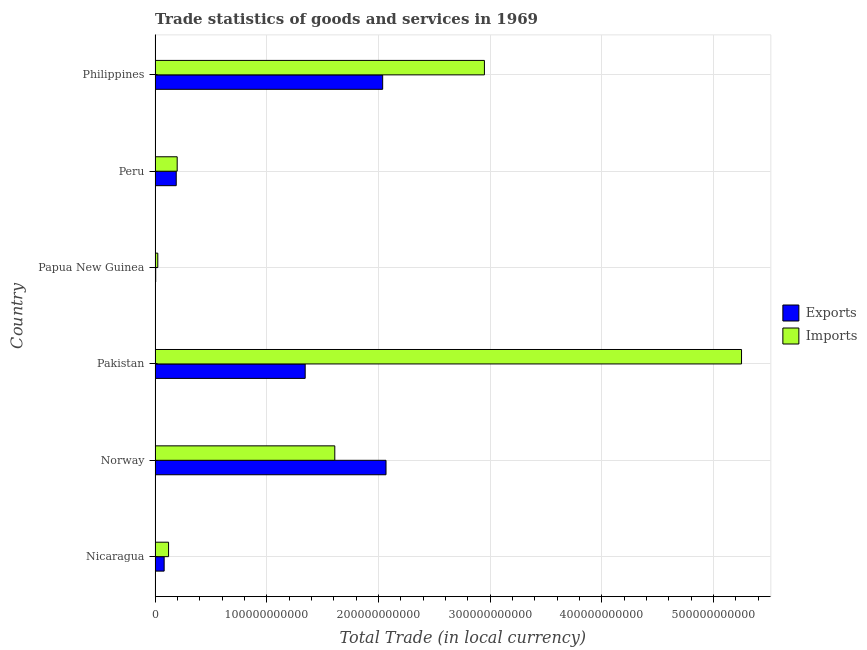How many different coloured bars are there?
Your answer should be compact. 2. How many groups of bars are there?
Offer a terse response. 6. Are the number of bars per tick equal to the number of legend labels?
Your answer should be very brief. Yes. Are the number of bars on each tick of the Y-axis equal?
Ensure brevity in your answer.  Yes. How many bars are there on the 5th tick from the top?
Your answer should be very brief. 2. What is the label of the 1st group of bars from the top?
Offer a terse response. Philippines. In how many cases, is the number of bars for a given country not equal to the number of legend labels?
Your answer should be compact. 0. What is the export of goods and services in Papua New Guinea?
Give a very brief answer. 5.80e+08. Across all countries, what is the maximum imports of goods and services?
Make the answer very short. 5.25e+11. Across all countries, what is the minimum imports of goods and services?
Provide a succinct answer. 2.45e+09. In which country was the imports of goods and services maximum?
Provide a succinct answer. Pakistan. In which country was the export of goods and services minimum?
Provide a succinct answer. Papua New Guinea. What is the total imports of goods and services in the graph?
Give a very brief answer. 1.02e+12. What is the difference between the export of goods and services in Pakistan and that in Peru?
Your answer should be compact. 1.15e+11. What is the difference between the export of goods and services in Peru and the imports of goods and services in Nicaragua?
Your answer should be very brief. 6.88e+09. What is the average export of goods and services per country?
Offer a very short reply. 9.55e+1. What is the difference between the imports of goods and services and export of goods and services in Norway?
Provide a short and direct response. -4.59e+1. What is the ratio of the imports of goods and services in Nicaragua to that in Papua New Guinea?
Offer a very short reply. 4.94. Is the difference between the export of goods and services in Nicaragua and Peru greater than the difference between the imports of goods and services in Nicaragua and Peru?
Give a very brief answer. No. What is the difference between the highest and the second highest export of goods and services?
Ensure brevity in your answer.  2.99e+09. What is the difference between the highest and the lowest imports of goods and services?
Provide a succinct answer. 5.23e+11. Is the sum of the export of goods and services in Papua New Guinea and Philippines greater than the maximum imports of goods and services across all countries?
Provide a succinct answer. No. What does the 1st bar from the top in Papua New Guinea represents?
Offer a terse response. Imports. What does the 2nd bar from the bottom in Norway represents?
Ensure brevity in your answer.  Imports. Are all the bars in the graph horizontal?
Your answer should be compact. Yes. What is the difference between two consecutive major ticks on the X-axis?
Make the answer very short. 1.00e+11. How many legend labels are there?
Your answer should be very brief. 2. How are the legend labels stacked?
Keep it short and to the point. Vertical. What is the title of the graph?
Make the answer very short. Trade statistics of goods and services in 1969. Does "Not attending school" appear as one of the legend labels in the graph?
Your answer should be compact. No. What is the label or title of the X-axis?
Offer a terse response. Total Trade (in local currency). What is the label or title of the Y-axis?
Offer a terse response. Country. What is the Total Trade (in local currency) in Exports in Nicaragua?
Offer a very short reply. 8.14e+09. What is the Total Trade (in local currency) of Imports in Nicaragua?
Provide a succinct answer. 1.21e+1. What is the Total Trade (in local currency) of Exports in Norway?
Your response must be concise. 2.07e+11. What is the Total Trade (in local currency) in Imports in Norway?
Provide a succinct answer. 1.61e+11. What is the Total Trade (in local currency) in Exports in Pakistan?
Ensure brevity in your answer.  1.34e+11. What is the Total Trade (in local currency) in Imports in Pakistan?
Provide a short and direct response. 5.25e+11. What is the Total Trade (in local currency) in Exports in Papua New Guinea?
Ensure brevity in your answer.  5.80e+08. What is the Total Trade (in local currency) of Imports in Papua New Guinea?
Your response must be concise. 2.45e+09. What is the Total Trade (in local currency) of Exports in Peru?
Your answer should be very brief. 1.90e+1. What is the Total Trade (in local currency) in Imports in Peru?
Offer a terse response. 1.98e+1. What is the Total Trade (in local currency) in Exports in Philippines?
Offer a terse response. 2.04e+11. What is the Total Trade (in local currency) in Imports in Philippines?
Your answer should be very brief. 2.95e+11. Across all countries, what is the maximum Total Trade (in local currency) in Exports?
Provide a short and direct response. 2.07e+11. Across all countries, what is the maximum Total Trade (in local currency) of Imports?
Make the answer very short. 5.25e+11. Across all countries, what is the minimum Total Trade (in local currency) of Exports?
Offer a very short reply. 5.80e+08. Across all countries, what is the minimum Total Trade (in local currency) in Imports?
Provide a short and direct response. 2.45e+09. What is the total Total Trade (in local currency) of Exports in the graph?
Keep it short and to the point. 5.73e+11. What is the total Total Trade (in local currency) in Imports in the graph?
Keep it short and to the point. 1.02e+12. What is the difference between the Total Trade (in local currency) of Exports in Nicaragua and that in Norway?
Provide a succinct answer. -1.99e+11. What is the difference between the Total Trade (in local currency) in Imports in Nicaragua and that in Norway?
Offer a very short reply. -1.49e+11. What is the difference between the Total Trade (in local currency) of Exports in Nicaragua and that in Pakistan?
Offer a very short reply. -1.26e+11. What is the difference between the Total Trade (in local currency) in Imports in Nicaragua and that in Pakistan?
Your response must be concise. -5.13e+11. What is the difference between the Total Trade (in local currency) of Exports in Nicaragua and that in Papua New Guinea?
Your answer should be compact. 7.56e+09. What is the difference between the Total Trade (in local currency) in Imports in Nicaragua and that in Papua New Guinea?
Offer a very short reply. 9.64e+09. What is the difference between the Total Trade (in local currency) of Exports in Nicaragua and that in Peru?
Your response must be concise. -1.08e+1. What is the difference between the Total Trade (in local currency) of Imports in Nicaragua and that in Peru?
Your answer should be compact. -7.73e+09. What is the difference between the Total Trade (in local currency) in Exports in Nicaragua and that in Philippines?
Your response must be concise. -1.96e+11. What is the difference between the Total Trade (in local currency) in Imports in Nicaragua and that in Philippines?
Make the answer very short. -2.83e+11. What is the difference between the Total Trade (in local currency) of Exports in Norway and that in Pakistan?
Keep it short and to the point. 7.24e+1. What is the difference between the Total Trade (in local currency) of Imports in Norway and that in Pakistan?
Give a very brief answer. -3.64e+11. What is the difference between the Total Trade (in local currency) of Exports in Norway and that in Papua New Guinea?
Offer a terse response. 2.06e+11. What is the difference between the Total Trade (in local currency) of Imports in Norway and that in Papua New Guinea?
Make the answer very short. 1.58e+11. What is the difference between the Total Trade (in local currency) in Exports in Norway and that in Peru?
Your answer should be very brief. 1.88e+11. What is the difference between the Total Trade (in local currency) in Imports in Norway and that in Peru?
Your response must be concise. 1.41e+11. What is the difference between the Total Trade (in local currency) of Exports in Norway and that in Philippines?
Offer a very short reply. 2.99e+09. What is the difference between the Total Trade (in local currency) of Imports in Norway and that in Philippines?
Give a very brief answer. -1.34e+11. What is the difference between the Total Trade (in local currency) in Exports in Pakistan and that in Papua New Guinea?
Ensure brevity in your answer.  1.34e+11. What is the difference between the Total Trade (in local currency) in Imports in Pakistan and that in Papua New Guinea?
Your answer should be very brief. 5.23e+11. What is the difference between the Total Trade (in local currency) in Exports in Pakistan and that in Peru?
Your answer should be very brief. 1.15e+11. What is the difference between the Total Trade (in local currency) in Imports in Pakistan and that in Peru?
Keep it short and to the point. 5.05e+11. What is the difference between the Total Trade (in local currency) in Exports in Pakistan and that in Philippines?
Provide a succinct answer. -6.94e+1. What is the difference between the Total Trade (in local currency) in Imports in Pakistan and that in Philippines?
Offer a terse response. 2.30e+11. What is the difference between the Total Trade (in local currency) in Exports in Papua New Guinea and that in Peru?
Ensure brevity in your answer.  -1.84e+1. What is the difference between the Total Trade (in local currency) in Imports in Papua New Guinea and that in Peru?
Give a very brief answer. -1.74e+1. What is the difference between the Total Trade (in local currency) of Exports in Papua New Guinea and that in Philippines?
Ensure brevity in your answer.  -2.03e+11. What is the difference between the Total Trade (in local currency) of Imports in Papua New Guinea and that in Philippines?
Ensure brevity in your answer.  -2.92e+11. What is the difference between the Total Trade (in local currency) in Exports in Peru and that in Philippines?
Provide a short and direct response. -1.85e+11. What is the difference between the Total Trade (in local currency) in Imports in Peru and that in Philippines?
Ensure brevity in your answer.  -2.75e+11. What is the difference between the Total Trade (in local currency) of Exports in Nicaragua and the Total Trade (in local currency) of Imports in Norway?
Give a very brief answer. -1.53e+11. What is the difference between the Total Trade (in local currency) in Exports in Nicaragua and the Total Trade (in local currency) in Imports in Pakistan?
Your response must be concise. -5.17e+11. What is the difference between the Total Trade (in local currency) of Exports in Nicaragua and the Total Trade (in local currency) of Imports in Papua New Guinea?
Give a very brief answer. 5.69e+09. What is the difference between the Total Trade (in local currency) in Exports in Nicaragua and the Total Trade (in local currency) in Imports in Peru?
Offer a very short reply. -1.17e+1. What is the difference between the Total Trade (in local currency) in Exports in Nicaragua and the Total Trade (in local currency) in Imports in Philippines?
Offer a very short reply. -2.87e+11. What is the difference between the Total Trade (in local currency) in Exports in Norway and the Total Trade (in local currency) in Imports in Pakistan?
Ensure brevity in your answer.  -3.18e+11. What is the difference between the Total Trade (in local currency) in Exports in Norway and the Total Trade (in local currency) in Imports in Papua New Guinea?
Your answer should be compact. 2.04e+11. What is the difference between the Total Trade (in local currency) of Exports in Norway and the Total Trade (in local currency) of Imports in Peru?
Your answer should be compact. 1.87e+11. What is the difference between the Total Trade (in local currency) of Exports in Norway and the Total Trade (in local currency) of Imports in Philippines?
Provide a succinct answer. -8.81e+1. What is the difference between the Total Trade (in local currency) of Exports in Pakistan and the Total Trade (in local currency) of Imports in Papua New Guinea?
Give a very brief answer. 1.32e+11. What is the difference between the Total Trade (in local currency) of Exports in Pakistan and the Total Trade (in local currency) of Imports in Peru?
Make the answer very short. 1.15e+11. What is the difference between the Total Trade (in local currency) in Exports in Pakistan and the Total Trade (in local currency) in Imports in Philippines?
Keep it short and to the point. -1.60e+11. What is the difference between the Total Trade (in local currency) in Exports in Papua New Guinea and the Total Trade (in local currency) in Imports in Peru?
Provide a succinct answer. -1.92e+1. What is the difference between the Total Trade (in local currency) of Exports in Papua New Guinea and the Total Trade (in local currency) of Imports in Philippines?
Your response must be concise. -2.94e+11. What is the difference between the Total Trade (in local currency) in Exports in Peru and the Total Trade (in local currency) in Imports in Philippines?
Offer a very short reply. -2.76e+11. What is the average Total Trade (in local currency) of Exports per country?
Keep it short and to the point. 9.55e+1. What is the average Total Trade (in local currency) of Imports per country?
Offer a very short reply. 1.69e+11. What is the difference between the Total Trade (in local currency) in Exports and Total Trade (in local currency) in Imports in Nicaragua?
Offer a very short reply. -3.94e+09. What is the difference between the Total Trade (in local currency) in Exports and Total Trade (in local currency) in Imports in Norway?
Offer a very short reply. 4.59e+1. What is the difference between the Total Trade (in local currency) in Exports and Total Trade (in local currency) in Imports in Pakistan?
Make the answer very short. -3.91e+11. What is the difference between the Total Trade (in local currency) in Exports and Total Trade (in local currency) in Imports in Papua New Guinea?
Provide a succinct answer. -1.87e+09. What is the difference between the Total Trade (in local currency) in Exports and Total Trade (in local currency) in Imports in Peru?
Your answer should be very brief. -8.51e+08. What is the difference between the Total Trade (in local currency) in Exports and Total Trade (in local currency) in Imports in Philippines?
Offer a very short reply. -9.11e+1. What is the ratio of the Total Trade (in local currency) of Exports in Nicaragua to that in Norway?
Ensure brevity in your answer.  0.04. What is the ratio of the Total Trade (in local currency) in Imports in Nicaragua to that in Norway?
Give a very brief answer. 0.08. What is the ratio of the Total Trade (in local currency) of Exports in Nicaragua to that in Pakistan?
Provide a succinct answer. 0.06. What is the ratio of the Total Trade (in local currency) in Imports in Nicaragua to that in Pakistan?
Make the answer very short. 0.02. What is the ratio of the Total Trade (in local currency) in Exports in Nicaragua to that in Papua New Guinea?
Make the answer very short. 14.03. What is the ratio of the Total Trade (in local currency) in Imports in Nicaragua to that in Papua New Guinea?
Ensure brevity in your answer.  4.94. What is the ratio of the Total Trade (in local currency) of Exports in Nicaragua to that in Peru?
Offer a very short reply. 0.43. What is the ratio of the Total Trade (in local currency) of Imports in Nicaragua to that in Peru?
Your response must be concise. 0.61. What is the ratio of the Total Trade (in local currency) of Exports in Nicaragua to that in Philippines?
Make the answer very short. 0.04. What is the ratio of the Total Trade (in local currency) of Imports in Nicaragua to that in Philippines?
Your response must be concise. 0.04. What is the ratio of the Total Trade (in local currency) in Exports in Norway to that in Pakistan?
Make the answer very short. 1.54. What is the ratio of the Total Trade (in local currency) in Imports in Norway to that in Pakistan?
Keep it short and to the point. 0.31. What is the ratio of the Total Trade (in local currency) in Exports in Norway to that in Papua New Guinea?
Ensure brevity in your answer.  356.27. What is the ratio of the Total Trade (in local currency) of Imports in Norway to that in Papua New Guinea?
Offer a terse response. 65.74. What is the ratio of the Total Trade (in local currency) of Exports in Norway to that in Peru?
Your response must be concise. 10.91. What is the ratio of the Total Trade (in local currency) of Imports in Norway to that in Peru?
Your answer should be very brief. 8.12. What is the ratio of the Total Trade (in local currency) in Exports in Norway to that in Philippines?
Make the answer very short. 1.01. What is the ratio of the Total Trade (in local currency) in Imports in Norway to that in Philippines?
Provide a short and direct response. 0.55. What is the ratio of the Total Trade (in local currency) of Exports in Pakistan to that in Papua New Guinea?
Provide a short and direct response. 231.58. What is the ratio of the Total Trade (in local currency) of Imports in Pakistan to that in Papua New Guinea?
Provide a short and direct response. 214.52. What is the ratio of the Total Trade (in local currency) in Exports in Pakistan to that in Peru?
Your answer should be very brief. 7.09. What is the ratio of the Total Trade (in local currency) of Imports in Pakistan to that in Peru?
Give a very brief answer. 26.51. What is the ratio of the Total Trade (in local currency) of Exports in Pakistan to that in Philippines?
Your answer should be compact. 0.66. What is the ratio of the Total Trade (in local currency) of Imports in Pakistan to that in Philippines?
Your answer should be very brief. 1.78. What is the ratio of the Total Trade (in local currency) of Exports in Papua New Guinea to that in Peru?
Your answer should be very brief. 0.03. What is the ratio of the Total Trade (in local currency) of Imports in Papua New Guinea to that in Peru?
Provide a succinct answer. 0.12. What is the ratio of the Total Trade (in local currency) of Exports in Papua New Guinea to that in Philippines?
Your answer should be very brief. 0. What is the ratio of the Total Trade (in local currency) of Imports in Papua New Guinea to that in Philippines?
Your answer should be very brief. 0.01. What is the ratio of the Total Trade (in local currency) of Exports in Peru to that in Philippines?
Give a very brief answer. 0.09. What is the ratio of the Total Trade (in local currency) in Imports in Peru to that in Philippines?
Your answer should be compact. 0.07. What is the difference between the highest and the second highest Total Trade (in local currency) of Exports?
Make the answer very short. 2.99e+09. What is the difference between the highest and the second highest Total Trade (in local currency) of Imports?
Your answer should be very brief. 2.30e+11. What is the difference between the highest and the lowest Total Trade (in local currency) in Exports?
Provide a succinct answer. 2.06e+11. What is the difference between the highest and the lowest Total Trade (in local currency) in Imports?
Offer a very short reply. 5.23e+11. 